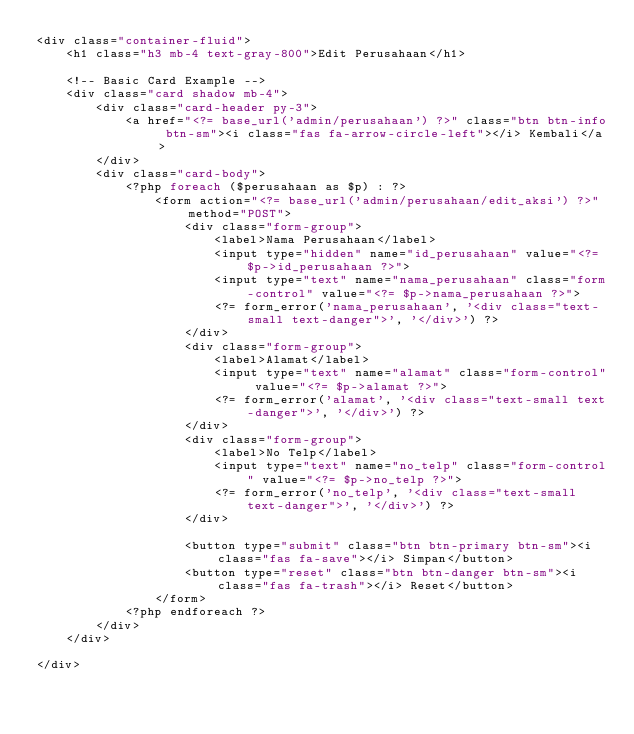<code> <loc_0><loc_0><loc_500><loc_500><_PHP_><div class="container-fluid">
    <h1 class="h3 mb-4 text-gray-800">Edit Perusahaan</h1>

    <!-- Basic Card Example -->
    <div class="card shadow mb-4">
        <div class="card-header py-3">
            <a href="<?= base_url('admin/perusahaan') ?>" class="btn btn-info btn-sm"><i class="fas fa-arrow-circle-left"></i> Kembali</a>
        </div>
        <div class="card-body">
            <?php foreach ($perusahaan as $p) : ?>
                <form action="<?= base_url('admin/perusahaan/edit_aksi') ?>" method="POST">
                    <div class="form-group">
                        <label>Nama Perusahaan</label>
                        <input type="hidden" name="id_perusahaan" value="<?= $p->id_perusahaan ?>">
                        <input type="text" name="nama_perusahaan" class="form-control" value="<?= $p->nama_perusahaan ?>">
                        <?= form_error('nama_perusahaan', '<div class="text-small text-danger">', '</div>') ?>
                    </div>
                    <div class="form-group">
                        <label>Alamat</label>
                        <input type="text" name="alamat" class="form-control" value="<?= $p->alamat ?>">
                        <?= form_error('alamat', '<div class="text-small text-danger">', '</div>') ?>
                    </div>
                    <div class="form-group">
                        <label>No Telp</label>
                        <input type="text" name="no_telp" class="form-control" value="<?= $p->no_telp ?>">
                        <?= form_error('no_telp', '<div class="text-small text-danger">', '</div>') ?>
                    </div>

                    <button type="submit" class="btn btn-primary btn-sm"><i class="fas fa-save"></i> Simpan</button>
                    <button type="reset" class="btn btn-danger btn-sm"><i class="fas fa-trash"></i> Reset</button>
                </form>
            <?php endforeach ?>
        </div>
    </div>

</div></code> 